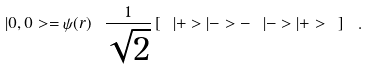Convert formula to latex. <formula><loc_0><loc_0><loc_500><loc_500>| 0 , 0 > = \psi ( r ) \ \frac { 1 } { \sqrt { 2 } } \left [ \ | + > | - > - \ | - > | + > \ \right ] \ .</formula> 